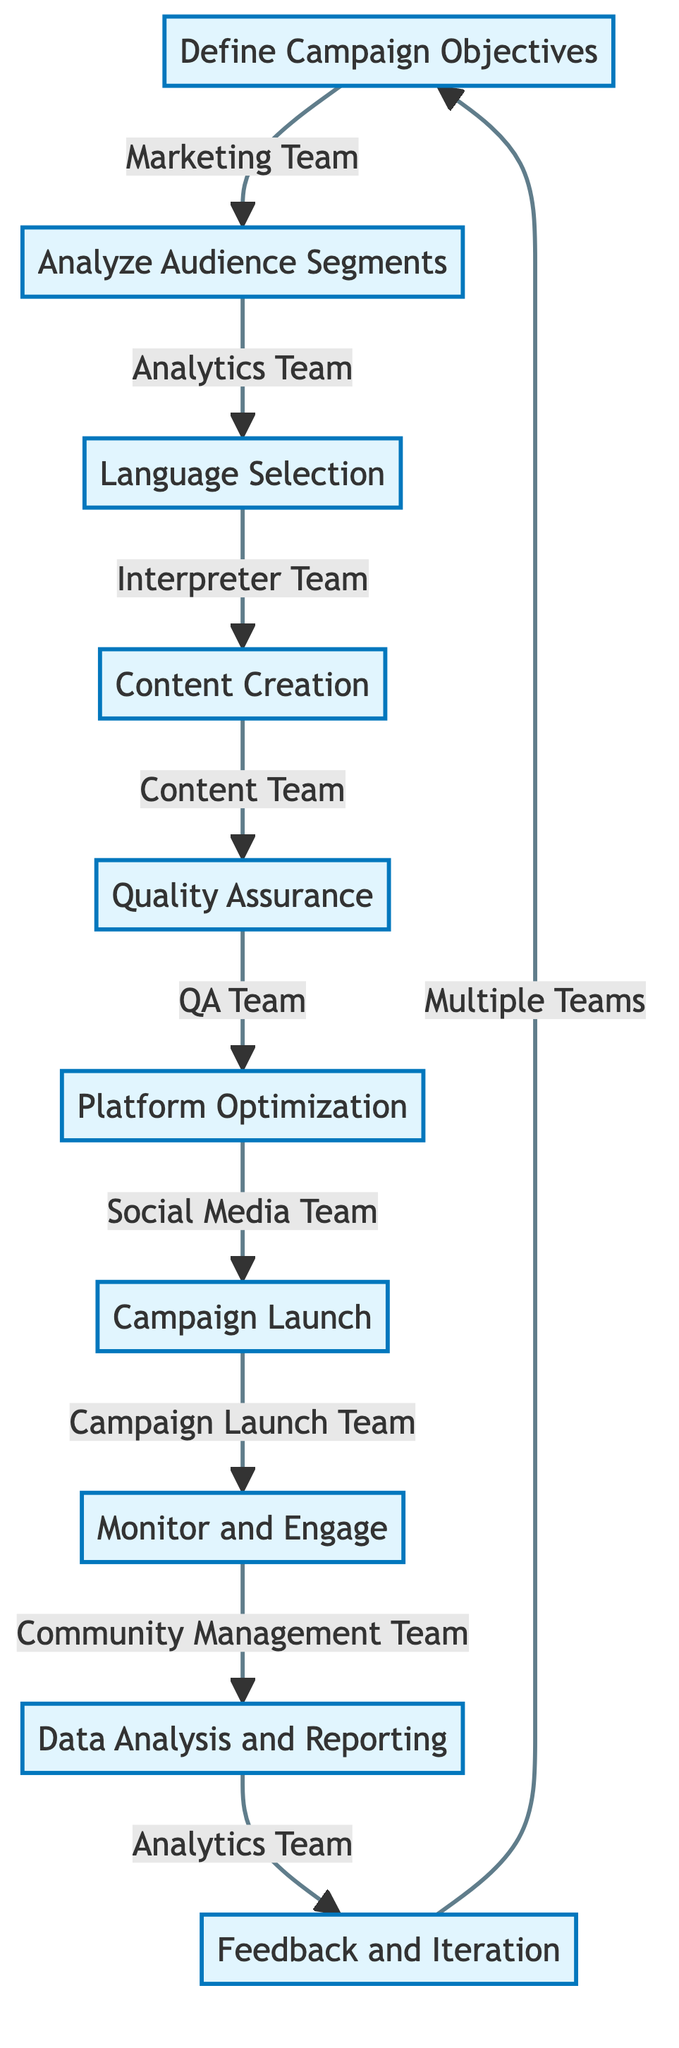What is the first step in the campaign strategy? The first step mentioned in the flow chart is "Define Campaign Objectives," which is directed by the Marketing Team.
Answer: Define Campaign Objectives How many teams are involved in the "Feedback and Iteration" step? The flow chart indicates that there are three teams involved in the "Feedback and Iteration" step: Interpreter Team, Content Team, and Marketing Team.
Answer: Three teams Which step comes immediately after "Quality Assurance"? Following "Quality Assurance," the next step is "Platform Optimization" as indicated by the directed flow in the diagram.
Answer: Platform Optimization What is the last step in the campaign process? The last step depicted in the flow diagram is "Feedback and Iteration," where various teams gather feedback and refine strategies.
Answer: Feedback and Iteration Which team is responsible for "Content Creation"? The responsibility for "Content Creation" in the flow chart is assigned to the Content Team.
Answer: Content Team What is the relationship between "Analyze Audience Segments" and "Language Selection"? "Analyze Audience Segments" directly leads to "Language Selection," indicating that the outcome of audience analysis informs language decisions.
Answer: Directly leads to Which teams are involved in "Monitor and Engage"? The team responsible for "Monitor and Engage" is the Community Management Team, as shown in the flowchart.
Answer: Community Management Team How many total steps are listed in the flow chart? The flow chart lists a total of ten steps from "Define Campaign Objectives" to "Feedback and Iteration."
Answer: Ten steps What is the main purpose of the "Data Analysis and Reporting" step? The main purpose of "Data Analysis and Reporting" is to analyze campaign performance and create reports, as stated in the flowchart.
Answer: Analyze campaign performance and create reports What action follows "Campaign Launch"? The action that follows "Campaign Launch" according to the flow chart is "Monitor and Engage," which involves tracking engagement.
Answer: Monitor and Engage 